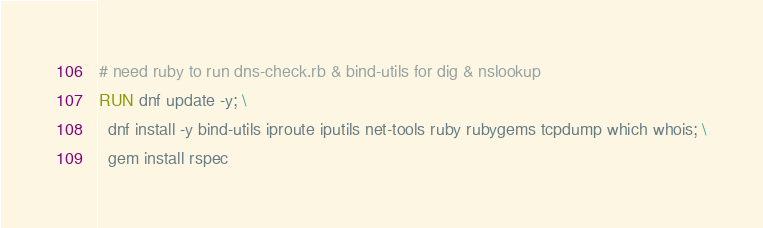Convert code to text. <code><loc_0><loc_0><loc_500><loc_500><_Dockerfile_>
# need ruby to run dns-check.rb & bind-utils for dig & nslookup
RUN dnf update -y; \
  dnf install -y bind-utils iproute iputils net-tools ruby rubygems tcpdump which whois; \
  gem install rspec
</code> 